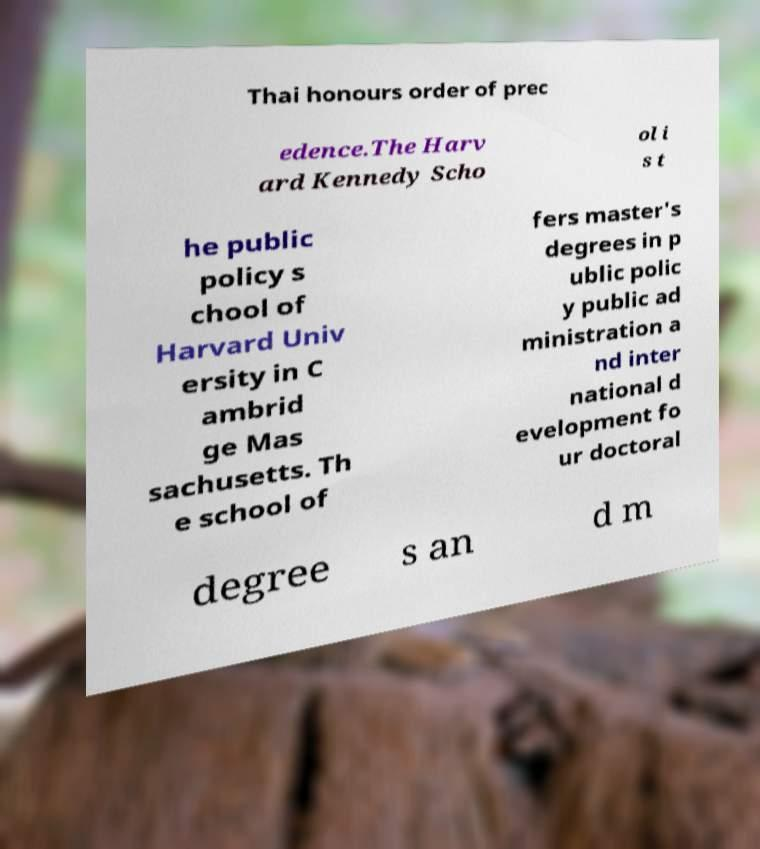Please read and relay the text visible in this image. What does it say? Thai honours order of prec edence.The Harv ard Kennedy Scho ol i s t he public policy s chool of Harvard Univ ersity in C ambrid ge Mas sachusetts. Th e school of fers master's degrees in p ublic polic y public ad ministration a nd inter national d evelopment fo ur doctoral degree s an d m 